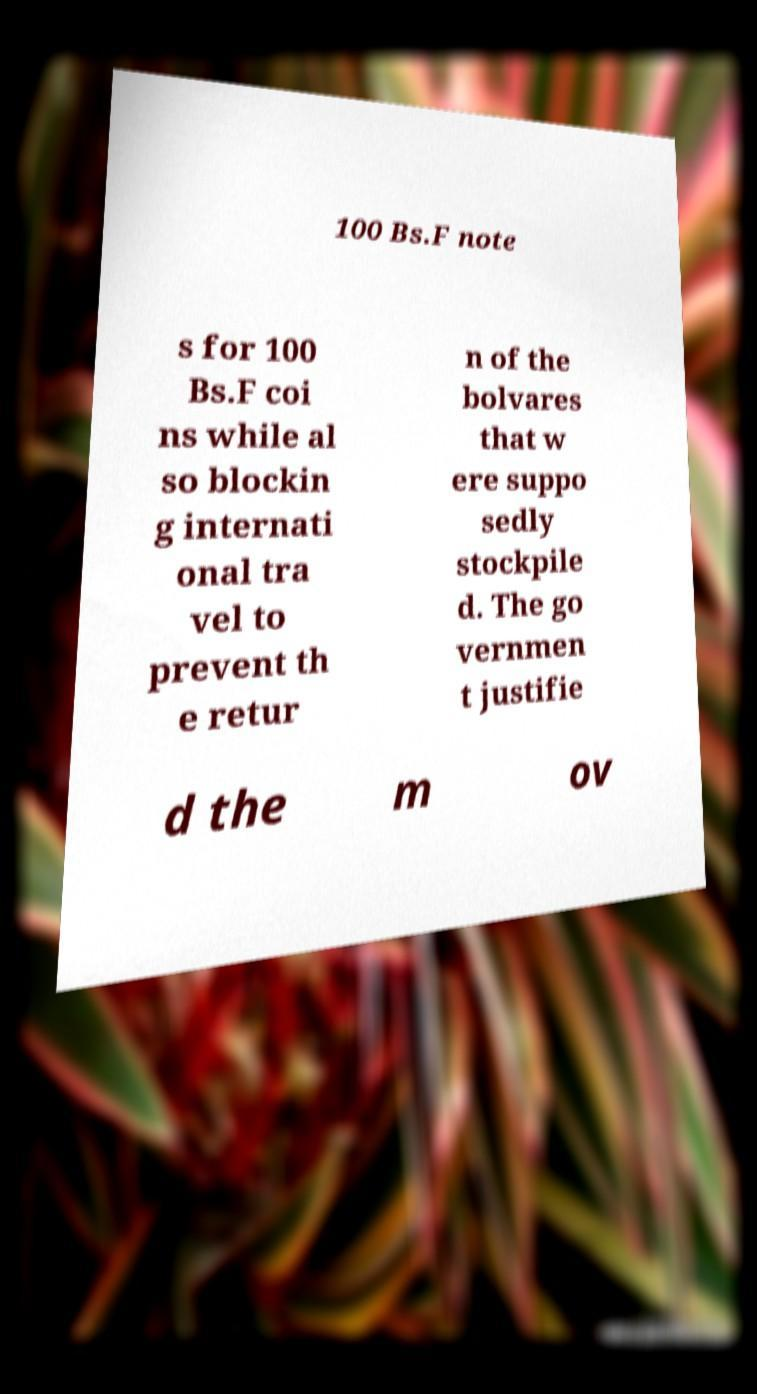Can you accurately transcribe the text from the provided image for me? 100 Bs.F note s for 100 Bs.F coi ns while al so blockin g internati onal tra vel to prevent th e retur n of the bolvares that w ere suppo sedly stockpile d. The go vernmen t justifie d the m ov 